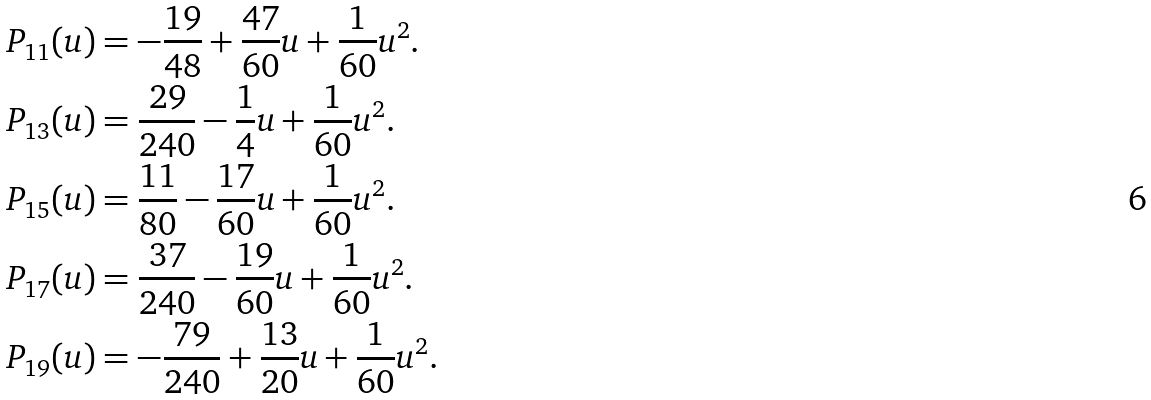<formula> <loc_0><loc_0><loc_500><loc_500>P _ { 1 1 } ( u ) & = - \frac { 1 9 } { 4 8 } + \frac { 4 7 } { 6 0 } u + \frac { 1 } { 6 0 } u ^ { 2 } . \\ P _ { 1 3 } ( u ) & = \frac { 2 9 } { 2 4 0 } - \frac { 1 } { 4 } u + \frac { 1 } { 6 0 } u ^ { 2 } . \\ P _ { 1 5 } ( u ) & = \frac { 1 1 } { 8 0 } - \frac { 1 7 } { 6 0 } u + \frac { 1 } { 6 0 } u ^ { 2 } . \\ P _ { 1 7 } ( u ) & = \frac { 3 7 } { 2 4 0 } - \frac { 1 9 } { 6 0 } u + \frac { 1 } { 6 0 } u ^ { 2 } . \\ P _ { 1 9 } ( u ) & = - \frac { 7 9 } { 2 4 0 } + \frac { 1 3 } { 2 0 } u + \frac { 1 } { 6 0 } u ^ { 2 } . \\</formula> 